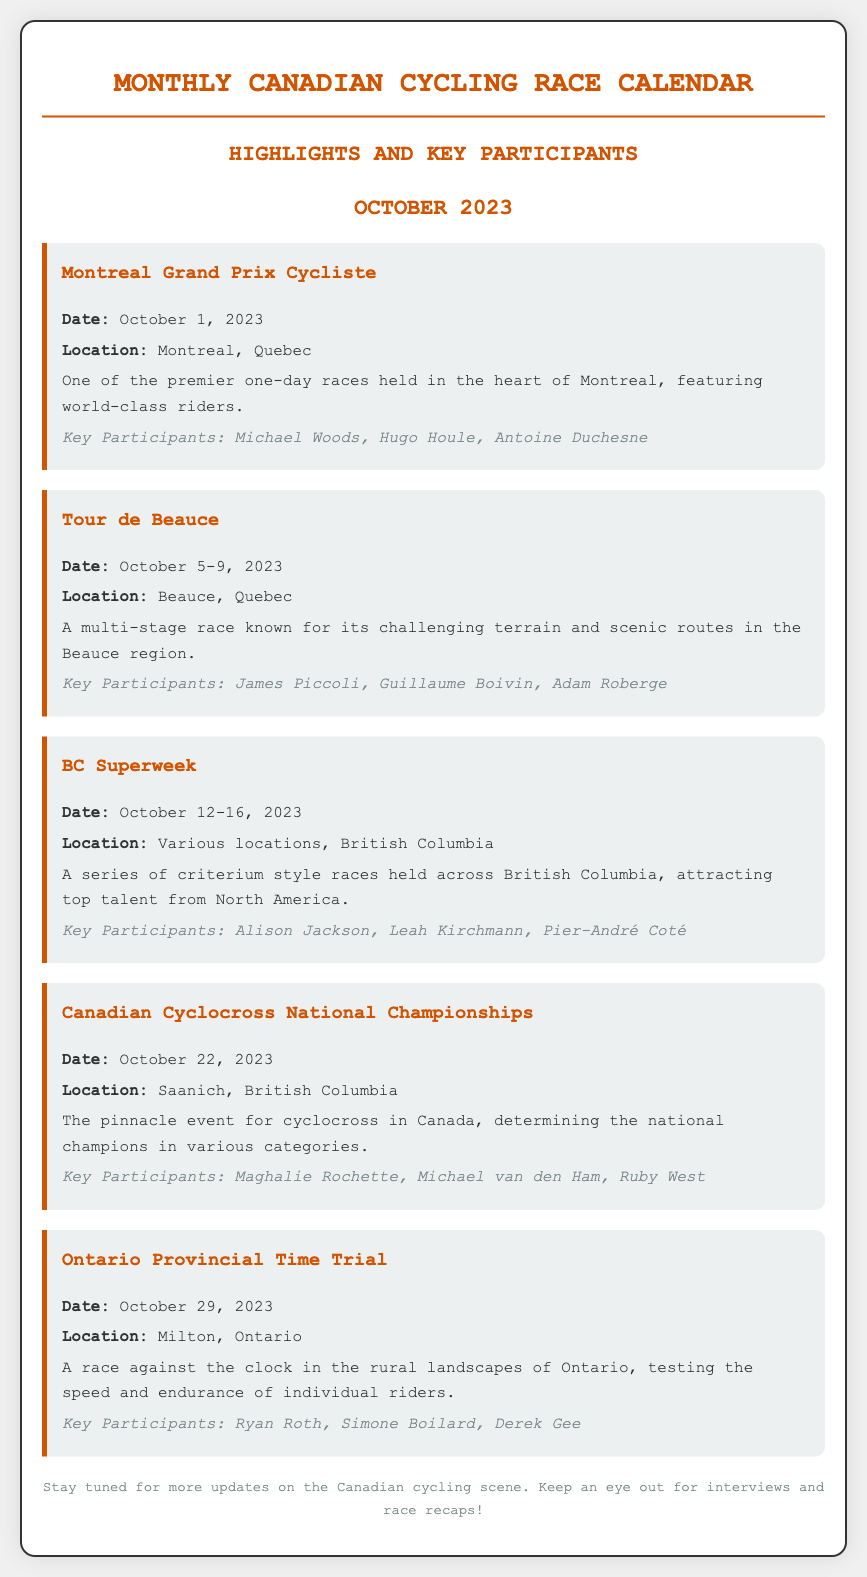what is the date of the Montreal Grand Prix Cycliste? The date is specified in the race section for the Montreal Grand Prix Cycliste, which is October 1, 2023.
Answer: October 1, 2023 which race takes place last in October? The last race listed in October is the Ontario Provincial Time Trial, occurring on October 29, 2023.
Answer: Ontario Provincial Time Trial who are the key participants in the BC Superweek? The document lists key participants specifically for the BC Superweek, which are Alison Jackson, Leah Kirchmann, Pier-André Coté.
Answer: Alison Jackson, Leah Kirchmann, Pier-André Coté how many races are scheduled in October? Counting all the races listed in the document, there are a total of five races scheduled for October 2023.
Answer: 5 where is the Canadian Cyclocross National Championships being held? The location is identified in the section about the Canadian Cyclocross National Championships as Saanich, British Columbia.
Answer: Saanich, British Columbia what type of race is the Tour de Beauce? The description of the Tour de Beauce categorizes it as a multi-stage race known for challenging terrain.
Answer: multi-stage race which province hosts the Ontario Provincial Time Trial? The document specifies that the Ontario Provincial Time Trial is hosted in Milton, Ontario.
Answer: Ontario which event features world-class riders? The Montreal Grand Prix Cycliste is noted for featuring world-class riders among its highlights.
Answer: Montreal Grand Prix Cycliste 